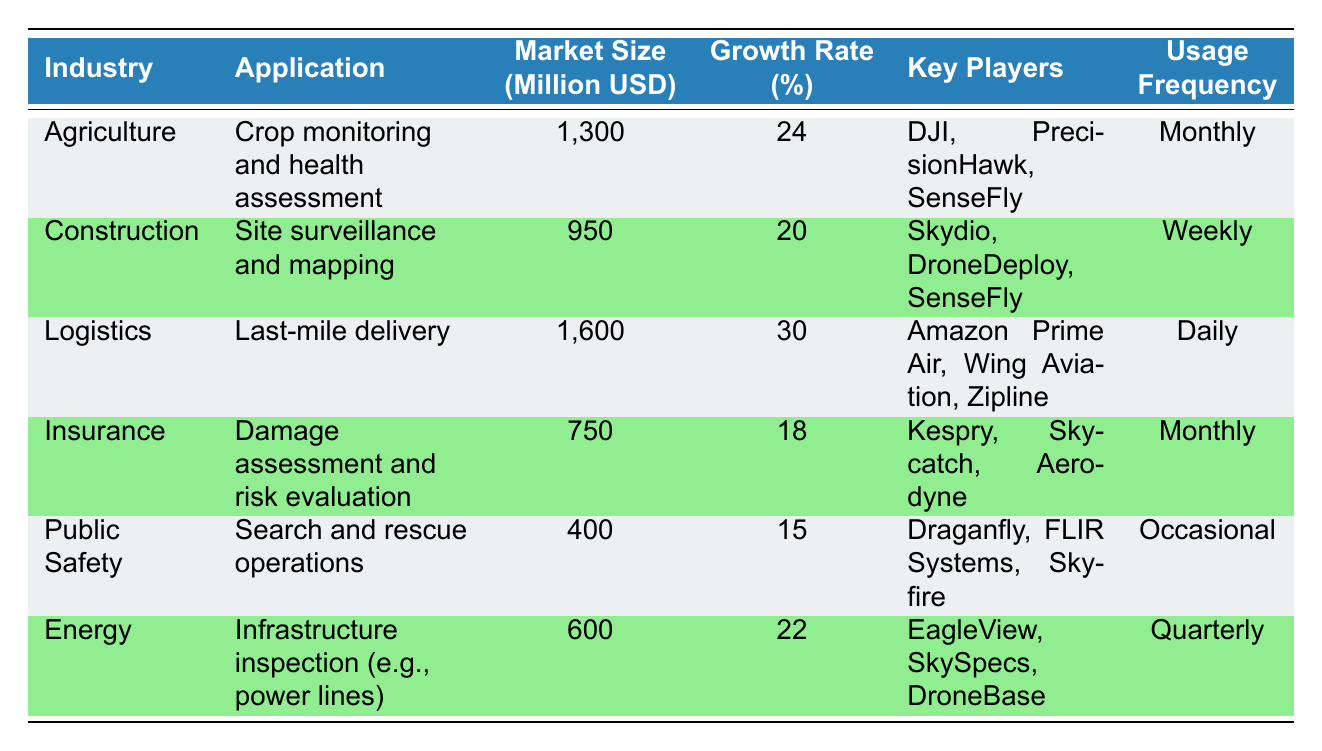What is the market size for the Logistics industry? The market size for the Logistics industry is listed in the table under the corresponding row. It shows a market size of 1600 million USD.
Answer: 1600 million USD Which industry has the highest growth rate? By examining the growth rate percentages in the table, the Logistics industry has the highest growth rate at 30%, which is greater than the other industries listed.
Answer: Logistics How many key players are mentioned for the Insurance industry? The table indicates that the Insurance industry has three key players: Kespry, Skycatch, and Aerodyne, as shown in the key players column for this row.
Answer: 3 What is the average market size of all industries listed? To calculate the average market size, first, we need to sum the market sizes: (1300 + 950 + 1600 + 750 + 400 + 600) = 4600 million USD. Then, we divide by the number of industries, which is 6, resulting in 4600/6 = 766.67 million USD.
Answer: 766.67 million USD Does the Agriculture industry have a higher market size than the Public Safety industry? Comparing the market sizes directly from the table, the Agriculture market size is 1300 million USD, while the Public Safety market size is 400 million USD. Since 1300 is greater than 400, the statement is true.
Answer: Yes Which industry has the least usage frequency? Looking at the usage frequency column, the Public Safety industry has "Occasional" listed, which is less frequent than any other usage frequencies recorded for the other industries.
Answer: Public Safety What is the total market size for the Agriculture and Insurance industries combined? First, we look up the market sizes for both industries in the table. Agriculture is 1300 million USD and Insurance is 750 million USD. Adding these together: 1300 + 750 = 2050 million USD gives us the total combined market size.
Answer: 2050 million USD Is the key player "DJI" associated with the Construction industry? By checking the key players associated with Construction in the table, we see that it lists Skydio, DroneDeploy, and SenseFly—not DJI. Therefore, the statement is false.
Answer: No What is the difference in growth rates between the Logistics and Public Safety industries? The growth rate for Logistics is 30% and for Public Safety, it is 15%. To find the difference, subtract the Public Safety rate from the Logistics rate: 30 - 15 = 15%.
Answer: 15% 